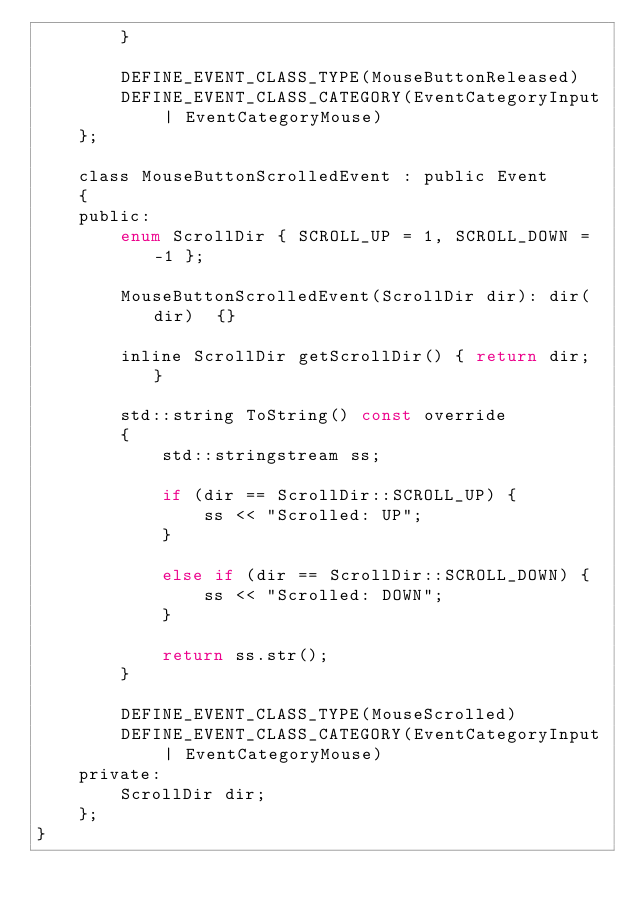Convert code to text. <code><loc_0><loc_0><loc_500><loc_500><_C_>		}

		DEFINE_EVENT_CLASS_TYPE(MouseButtonReleased)
		DEFINE_EVENT_CLASS_CATEGORY(EventCategoryInput | EventCategoryMouse)
	};

	class MouseButtonScrolledEvent : public Event
	{
	public:
		enum ScrollDir { SCROLL_UP = 1, SCROLL_DOWN = -1 };

		MouseButtonScrolledEvent(ScrollDir dir): dir(dir)  {}

		inline ScrollDir getScrollDir() { return dir; }

		std::string ToString() const override
		{
			std::stringstream ss;

			if (dir == ScrollDir::SCROLL_UP) {
				ss << "Scrolled: UP";
			}

			else if (dir == ScrollDir::SCROLL_DOWN) {
				ss << "Scrolled: DOWN";
			}
			
			return ss.str();
		}

		DEFINE_EVENT_CLASS_TYPE(MouseScrolled)
		DEFINE_EVENT_CLASS_CATEGORY(EventCategoryInput | EventCategoryMouse)
	private:
		ScrollDir dir;
	};
}</code> 